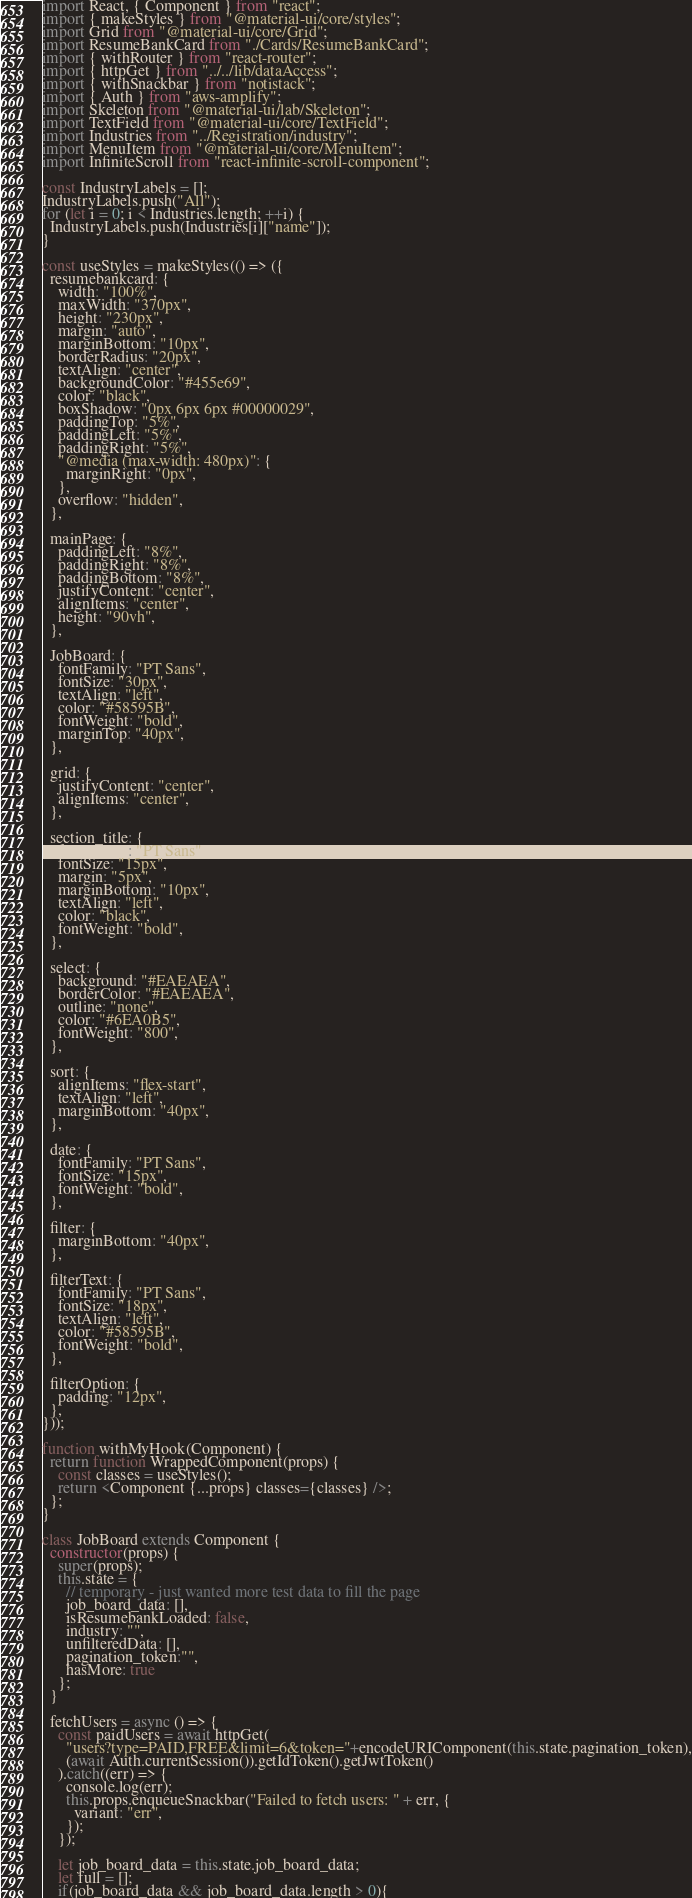Convert code to text. <code><loc_0><loc_0><loc_500><loc_500><_JavaScript_>import React, { Component } from "react";
import { makeStyles } from "@material-ui/core/styles";
import Grid from "@material-ui/core/Grid";
import ResumeBankCard from "./Cards/ResumeBankCard";
import { withRouter } from "react-router";
import { httpGet } from "../../lib/dataAccess";
import { withSnackbar } from "notistack";
import { Auth } from "aws-amplify";
import Skeleton from "@material-ui/lab/Skeleton";
import TextField from "@material-ui/core/TextField";
import Industries from "../Registration/industry";
import MenuItem from "@material-ui/core/MenuItem";
import InfiniteScroll from "react-infinite-scroll-component";

const IndustryLabels = [];
IndustryLabels.push("All");
for (let i = 0; i < Industries.length; ++i) {
  IndustryLabels.push(Industries[i]["name"]);
}

const useStyles = makeStyles(() => ({
  resumebankcard: {
    width: "100%",
    maxWidth: "370px",
    height: "230px",
    margin: "auto",
    marginBottom: "10px",
    borderRadius: "20px",
    textAlign: "center",
    backgroundColor: "#455e69",
    color: "black",
    boxShadow: "0px 6px 6px #00000029",
    paddingTop: "5%",
    paddingLeft: "5%",
    paddingRight: "5%",
    "@media (max-width: 480px)": {
      marginRight: "0px",
    },
    overflow: "hidden",
  },

  mainPage: {
    paddingLeft: "8%",
    paddingRight: "8%",
    paddingBottom: "8%",
    justifyContent: "center",
    alignItems: "center",
    height: "90vh",
  },

  JobBoard: {
    fontFamily: "PT Sans",
    fontSize: "30px",
    textAlign: "left",
    color: "#58595B",
    fontWeight: "bold",
    marginTop: "40px",
  },

  grid: {
    justifyContent: "center",
    alignItems: "center",
  },

  section_title: {
    fontFamily: "PT Sans",
    fontSize: "15px",
    margin: "5px",
    marginBottom: "10px",
    textAlign: "left",
    color: "black",
    fontWeight: "bold",
  },

  select: {
    background: "#EAEAEA",
    borderColor: "#EAEAEA",
    outline: "none",
    color: "#6EA0B5",
    fontWeight: "800",
  },

  sort: {
    alignItems: "flex-start",
    textAlign: "left",
    marginBottom: "40px",
  },

  date: {
    fontFamily: "PT Sans",
    fontSize: "15px",
    fontWeight: "bold",
  },

  filter: {
    marginBottom: "40px",
  },

  filterText: {
    fontFamily: "PT Sans",
    fontSize: "18px",
    textAlign: "left",
    color: "#58595B",
    fontWeight: "bold",
  },

  filterOption: {
    padding: "12px",
  },
}));

function withMyHook(Component) {
  return function WrappedComponent(props) {
    const classes = useStyles();
    return <Component {...props} classes={classes} />;
  };
}

class JobBoard extends Component {
  constructor(props) {
    super(props);
    this.state = {
      // temporary - just wanted more test data to fill the page
      job_board_data: [],
      isResumebankLoaded: false,
      industry: "",
      unfilteredData: [],
      pagination_token:"",
      hasMore: true
    };
  }

  fetchUsers = async () => {
    const paidUsers = await httpGet(
      "users?type=PAID,FREE&limit=6&token="+encodeURIComponent(this.state.pagination_token),
      (await Auth.currentSession()).getIdToken().getJwtToken()
    ).catch((err) => {
      console.log(err);
      this.props.enqueueSnackbar("Failed to fetch users: " + err, {
        variant: "err",
      });
    });

    let job_board_data = this.state.job_board_data;
    let full = [];
    if(job_board_data && job_board_data.length > 0){</code> 